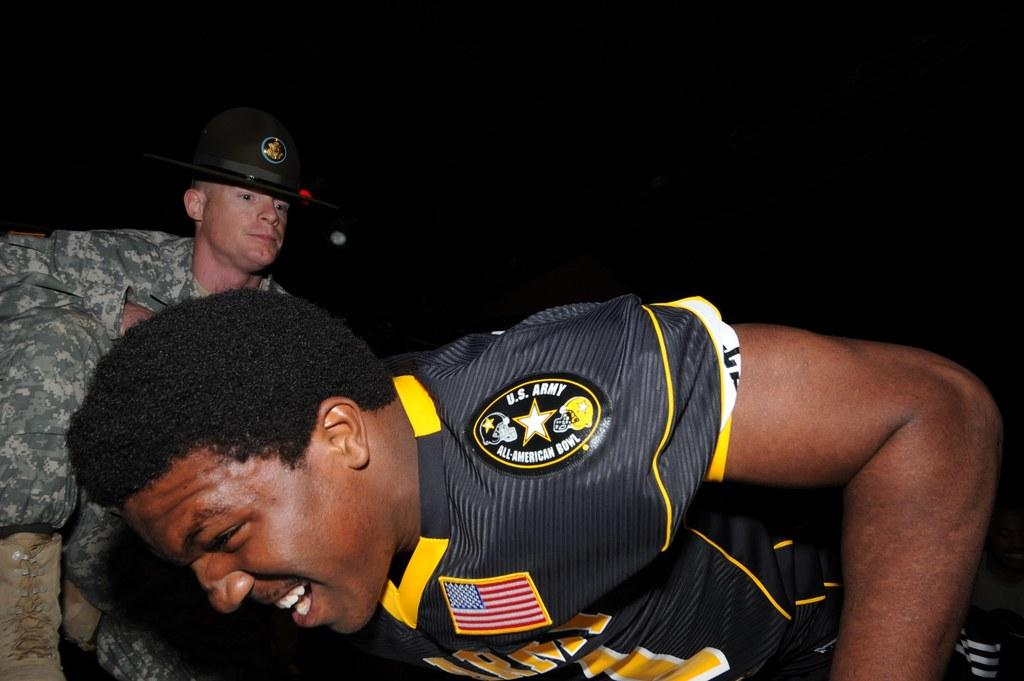Provide a one-sentence caption for the provided image. A football player celebrates at the U.S. Army All-American Bowl. 